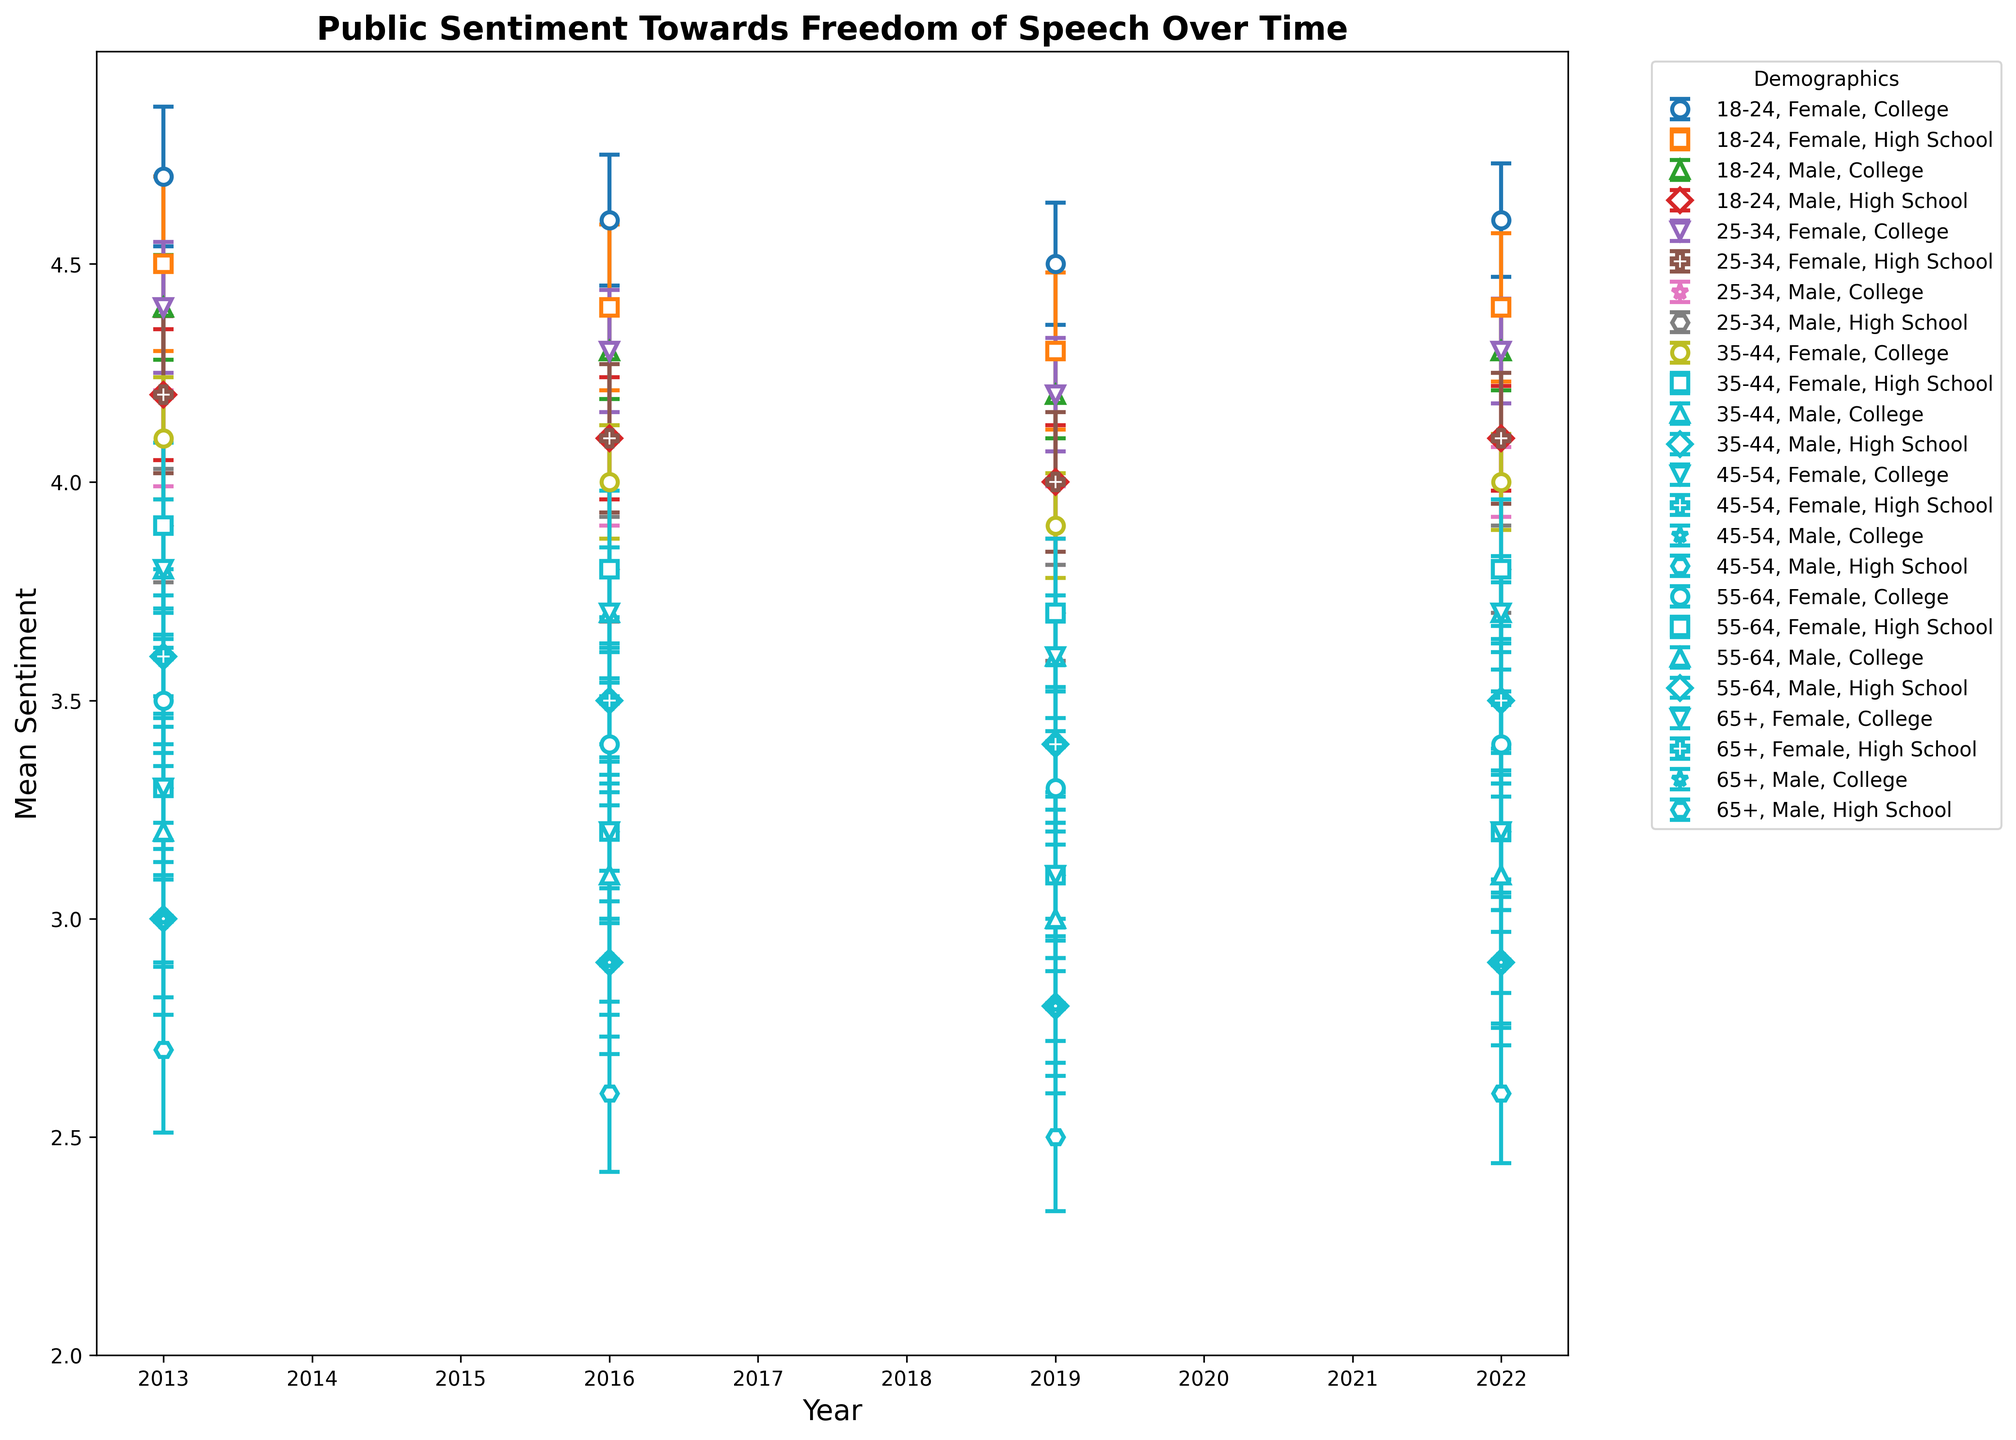Which age group and gender show the highest average sentiment towards freedom of speech? To determine the highest average sentiment, examine the figure and locate the highest data point. Compare the means across all age groups and genders.
Answer: 18-24 Female Which demographic category shows the most noticeable downward trend over time? Compare the slopes of the lines for each demographic category. Look for the line that consistently decreases from 2013 to 2022.
Answer: 65+ Male, High School Is there a significant difference in sentiment between males and females in the 25-34 age group with a College education in 2022? Find the sentiment values for both genders in the 25-34 age group with a college education in 2022. Compare the values to see if there is a noticeable difference.
Answer: No, the difference is 0.3 (4.0 for males, 4.3 for females) What is the average sentiment difference between males and females in the 55-64 age group across all education levels in 2016? Find the sentiment values for both genders in the 55-64 age group for each educational level in 2016. Calculate the average difference [(3.1 - 2.9 + 3.4 - 3.2) / 2].
Answer: 0.2 How does the sentiment trend for the 18-24 age group with a High School education compare to the same group with a College education? Compare the lines for the 18-24 High School and 18-24 College groups. Observe if one line increases or decreases more than the other over time.
Answer: High School remains slightly lower and more stable, while College shows a slightly more positive trend 